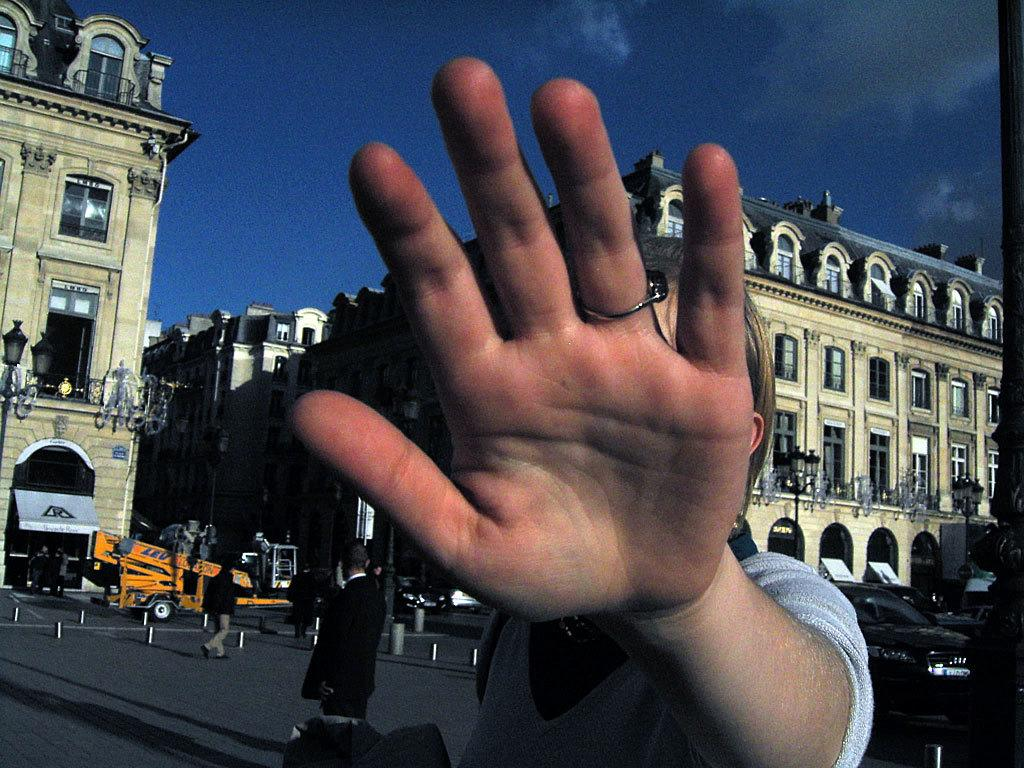What type of structures can be seen in the image? There are buildings in the image. What else can be seen on the ground in the image? Vehicles are visible on the road at the bottom of the image. Are there any living beings present in the image? Yes, there are people in the image. What can be seen in the distance in the image? The sky is visible in the background of the image. What type of plant is the woman wearing as a dress in the image? There is no woman wearing a plant as a dress in the image. 